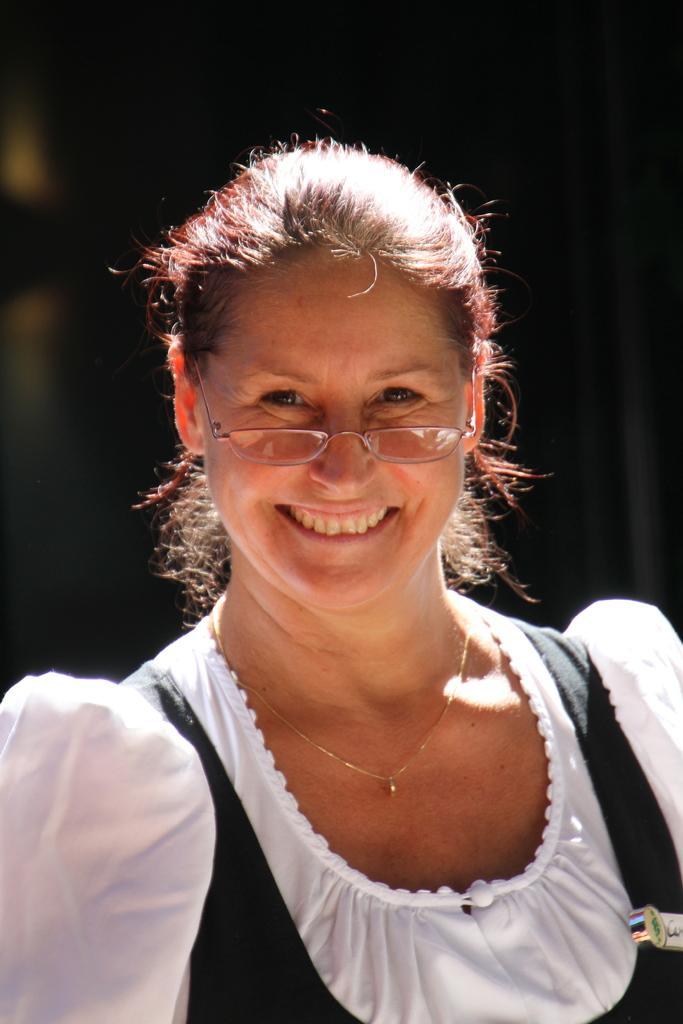Please provide a concise description of this image. This image consists of a woman wearing a black and white dress. The background is blurred. 